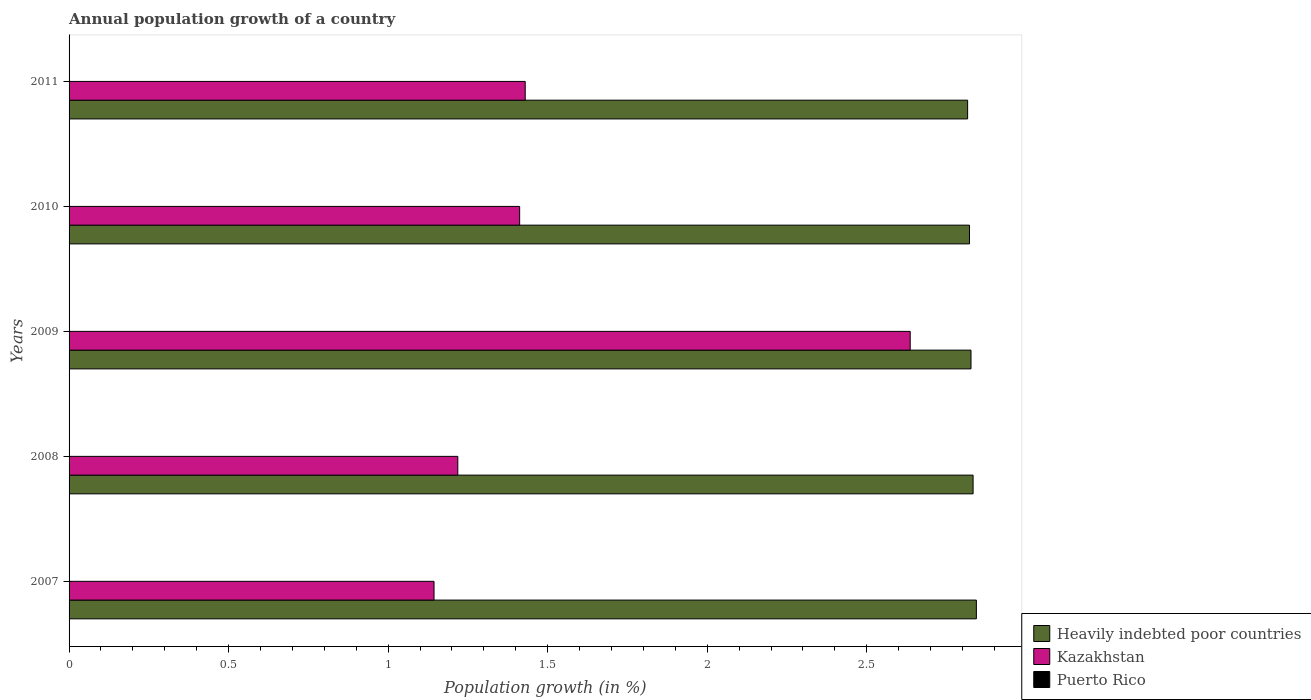How many groups of bars are there?
Keep it short and to the point. 5. How many bars are there on the 3rd tick from the top?
Offer a very short reply. 2. What is the label of the 5th group of bars from the top?
Ensure brevity in your answer.  2007. In how many cases, is the number of bars for a given year not equal to the number of legend labels?
Make the answer very short. 5. Across all years, what is the maximum annual population growth in Kazakhstan?
Your response must be concise. 2.64. Across all years, what is the minimum annual population growth in Kazakhstan?
Offer a terse response. 1.14. In which year was the annual population growth in Heavily indebted poor countries maximum?
Provide a short and direct response. 2007. What is the difference between the annual population growth in Kazakhstan in 2008 and that in 2010?
Keep it short and to the point. -0.19. What is the difference between the annual population growth in Puerto Rico in 2008 and the annual population growth in Heavily indebted poor countries in 2007?
Provide a succinct answer. -2.84. What is the average annual population growth in Kazakhstan per year?
Your answer should be very brief. 1.57. In the year 2009, what is the difference between the annual population growth in Kazakhstan and annual population growth in Heavily indebted poor countries?
Make the answer very short. -0.19. In how many years, is the annual population growth in Puerto Rico greater than 1.1 %?
Give a very brief answer. 0. What is the ratio of the annual population growth in Heavily indebted poor countries in 2009 to that in 2011?
Offer a very short reply. 1. What is the difference between the highest and the second highest annual population growth in Heavily indebted poor countries?
Ensure brevity in your answer.  0.01. What is the difference between the highest and the lowest annual population growth in Kazakhstan?
Provide a succinct answer. 1.49. In how many years, is the annual population growth in Heavily indebted poor countries greater than the average annual population growth in Heavily indebted poor countries taken over all years?
Keep it short and to the point. 2. Is the sum of the annual population growth in Heavily indebted poor countries in 2008 and 2010 greater than the maximum annual population growth in Puerto Rico across all years?
Make the answer very short. Yes. How many bars are there?
Give a very brief answer. 10. Are all the bars in the graph horizontal?
Your answer should be compact. Yes. Does the graph contain any zero values?
Make the answer very short. Yes. How many legend labels are there?
Give a very brief answer. 3. How are the legend labels stacked?
Make the answer very short. Vertical. What is the title of the graph?
Make the answer very short. Annual population growth of a country. Does "Europe(all income levels)" appear as one of the legend labels in the graph?
Your response must be concise. No. What is the label or title of the X-axis?
Make the answer very short. Population growth (in %). What is the Population growth (in %) in Heavily indebted poor countries in 2007?
Your response must be concise. 2.84. What is the Population growth (in %) in Kazakhstan in 2007?
Provide a short and direct response. 1.14. What is the Population growth (in %) of Heavily indebted poor countries in 2008?
Your answer should be compact. 2.83. What is the Population growth (in %) in Kazakhstan in 2008?
Provide a short and direct response. 1.22. What is the Population growth (in %) in Puerto Rico in 2008?
Give a very brief answer. 0. What is the Population growth (in %) of Heavily indebted poor countries in 2009?
Provide a short and direct response. 2.83. What is the Population growth (in %) of Kazakhstan in 2009?
Offer a terse response. 2.64. What is the Population growth (in %) in Puerto Rico in 2009?
Offer a very short reply. 0. What is the Population growth (in %) of Heavily indebted poor countries in 2010?
Offer a terse response. 2.82. What is the Population growth (in %) in Kazakhstan in 2010?
Give a very brief answer. 1.41. What is the Population growth (in %) in Heavily indebted poor countries in 2011?
Keep it short and to the point. 2.82. What is the Population growth (in %) in Kazakhstan in 2011?
Provide a succinct answer. 1.43. What is the Population growth (in %) of Puerto Rico in 2011?
Provide a succinct answer. 0. Across all years, what is the maximum Population growth (in %) in Heavily indebted poor countries?
Your answer should be very brief. 2.84. Across all years, what is the maximum Population growth (in %) in Kazakhstan?
Give a very brief answer. 2.64. Across all years, what is the minimum Population growth (in %) in Heavily indebted poor countries?
Your response must be concise. 2.82. Across all years, what is the minimum Population growth (in %) of Kazakhstan?
Offer a terse response. 1.14. What is the total Population growth (in %) of Heavily indebted poor countries in the graph?
Your answer should be very brief. 14.14. What is the total Population growth (in %) of Kazakhstan in the graph?
Offer a very short reply. 7.84. What is the difference between the Population growth (in %) in Heavily indebted poor countries in 2007 and that in 2008?
Give a very brief answer. 0.01. What is the difference between the Population growth (in %) of Kazakhstan in 2007 and that in 2008?
Your answer should be compact. -0.07. What is the difference between the Population growth (in %) in Heavily indebted poor countries in 2007 and that in 2009?
Keep it short and to the point. 0.02. What is the difference between the Population growth (in %) in Kazakhstan in 2007 and that in 2009?
Your answer should be very brief. -1.49. What is the difference between the Population growth (in %) in Heavily indebted poor countries in 2007 and that in 2010?
Offer a very short reply. 0.02. What is the difference between the Population growth (in %) of Kazakhstan in 2007 and that in 2010?
Make the answer very short. -0.27. What is the difference between the Population growth (in %) of Heavily indebted poor countries in 2007 and that in 2011?
Your response must be concise. 0.03. What is the difference between the Population growth (in %) in Kazakhstan in 2007 and that in 2011?
Provide a short and direct response. -0.29. What is the difference between the Population growth (in %) of Heavily indebted poor countries in 2008 and that in 2009?
Keep it short and to the point. 0.01. What is the difference between the Population growth (in %) in Kazakhstan in 2008 and that in 2009?
Keep it short and to the point. -1.42. What is the difference between the Population growth (in %) of Heavily indebted poor countries in 2008 and that in 2010?
Provide a succinct answer. 0.01. What is the difference between the Population growth (in %) in Kazakhstan in 2008 and that in 2010?
Provide a short and direct response. -0.19. What is the difference between the Population growth (in %) of Heavily indebted poor countries in 2008 and that in 2011?
Keep it short and to the point. 0.02. What is the difference between the Population growth (in %) in Kazakhstan in 2008 and that in 2011?
Your answer should be very brief. -0.21. What is the difference between the Population growth (in %) of Heavily indebted poor countries in 2009 and that in 2010?
Keep it short and to the point. 0. What is the difference between the Population growth (in %) in Kazakhstan in 2009 and that in 2010?
Offer a very short reply. 1.22. What is the difference between the Population growth (in %) of Heavily indebted poor countries in 2009 and that in 2011?
Ensure brevity in your answer.  0.01. What is the difference between the Population growth (in %) in Kazakhstan in 2009 and that in 2011?
Give a very brief answer. 1.21. What is the difference between the Population growth (in %) of Heavily indebted poor countries in 2010 and that in 2011?
Offer a very short reply. 0.01. What is the difference between the Population growth (in %) in Kazakhstan in 2010 and that in 2011?
Provide a short and direct response. -0.02. What is the difference between the Population growth (in %) of Heavily indebted poor countries in 2007 and the Population growth (in %) of Kazakhstan in 2008?
Make the answer very short. 1.63. What is the difference between the Population growth (in %) in Heavily indebted poor countries in 2007 and the Population growth (in %) in Kazakhstan in 2009?
Your response must be concise. 0.21. What is the difference between the Population growth (in %) in Heavily indebted poor countries in 2007 and the Population growth (in %) in Kazakhstan in 2010?
Provide a succinct answer. 1.43. What is the difference between the Population growth (in %) of Heavily indebted poor countries in 2007 and the Population growth (in %) of Kazakhstan in 2011?
Make the answer very short. 1.41. What is the difference between the Population growth (in %) in Heavily indebted poor countries in 2008 and the Population growth (in %) in Kazakhstan in 2009?
Make the answer very short. 0.2. What is the difference between the Population growth (in %) in Heavily indebted poor countries in 2008 and the Population growth (in %) in Kazakhstan in 2010?
Your answer should be compact. 1.42. What is the difference between the Population growth (in %) in Heavily indebted poor countries in 2008 and the Population growth (in %) in Kazakhstan in 2011?
Offer a very short reply. 1.4. What is the difference between the Population growth (in %) in Heavily indebted poor countries in 2009 and the Population growth (in %) in Kazakhstan in 2010?
Ensure brevity in your answer.  1.41. What is the difference between the Population growth (in %) of Heavily indebted poor countries in 2009 and the Population growth (in %) of Kazakhstan in 2011?
Your answer should be very brief. 1.4. What is the difference between the Population growth (in %) in Heavily indebted poor countries in 2010 and the Population growth (in %) in Kazakhstan in 2011?
Give a very brief answer. 1.39. What is the average Population growth (in %) of Heavily indebted poor countries per year?
Keep it short and to the point. 2.83. What is the average Population growth (in %) of Kazakhstan per year?
Provide a succinct answer. 1.57. What is the average Population growth (in %) in Puerto Rico per year?
Provide a short and direct response. 0. In the year 2007, what is the difference between the Population growth (in %) of Heavily indebted poor countries and Population growth (in %) of Kazakhstan?
Provide a short and direct response. 1.7. In the year 2008, what is the difference between the Population growth (in %) of Heavily indebted poor countries and Population growth (in %) of Kazakhstan?
Provide a succinct answer. 1.61. In the year 2009, what is the difference between the Population growth (in %) in Heavily indebted poor countries and Population growth (in %) in Kazakhstan?
Your response must be concise. 0.19. In the year 2010, what is the difference between the Population growth (in %) in Heavily indebted poor countries and Population growth (in %) in Kazakhstan?
Your response must be concise. 1.41. In the year 2011, what is the difference between the Population growth (in %) in Heavily indebted poor countries and Population growth (in %) in Kazakhstan?
Make the answer very short. 1.39. What is the ratio of the Population growth (in %) in Kazakhstan in 2007 to that in 2008?
Your answer should be compact. 0.94. What is the ratio of the Population growth (in %) in Heavily indebted poor countries in 2007 to that in 2009?
Provide a short and direct response. 1.01. What is the ratio of the Population growth (in %) of Kazakhstan in 2007 to that in 2009?
Offer a terse response. 0.43. What is the ratio of the Population growth (in %) in Heavily indebted poor countries in 2007 to that in 2010?
Keep it short and to the point. 1.01. What is the ratio of the Population growth (in %) of Kazakhstan in 2007 to that in 2010?
Make the answer very short. 0.81. What is the ratio of the Population growth (in %) in Heavily indebted poor countries in 2007 to that in 2011?
Your response must be concise. 1.01. What is the ratio of the Population growth (in %) in Kazakhstan in 2007 to that in 2011?
Make the answer very short. 0.8. What is the ratio of the Population growth (in %) of Heavily indebted poor countries in 2008 to that in 2009?
Give a very brief answer. 1. What is the ratio of the Population growth (in %) in Kazakhstan in 2008 to that in 2009?
Give a very brief answer. 0.46. What is the ratio of the Population growth (in %) of Heavily indebted poor countries in 2008 to that in 2010?
Give a very brief answer. 1. What is the ratio of the Population growth (in %) of Kazakhstan in 2008 to that in 2010?
Your response must be concise. 0.86. What is the ratio of the Population growth (in %) of Kazakhstan in 2008 to that in 2011?
Make the answer very short. 0.85. What is the ratio of the Population growth (in %) of Kazakhstan in 2009 to that in 2010?
Provide a succinct answer. 1.87. What is the ratio of the Population growth (in %) in Kazakhstan in 2009 to that in 2011?
Your response must be concise. 1.84. What is the ratio of the Population growth (in %) of Kazakhstan in 2010 to that in 2011?
Your answer should be very brief. 0.99. What is the difference between the highest and the second highest Population growth (in %) of Heavily indebted poor countries?
Offer a terse response. 0.01. What is the difference between the highest and the second highest Population growth (in %) in Kazakhstan?
Provide a succinct answer. 1.21. What is the difference between the highest and the lowest Population growth (in %) in Heavily indebted poor countries?
Offer a very short reply. 0.03. What is the difference between the highest and the lowest Population growth (in %) of Kazakhstan?
Ensure brevity in your answer.  1.49. 